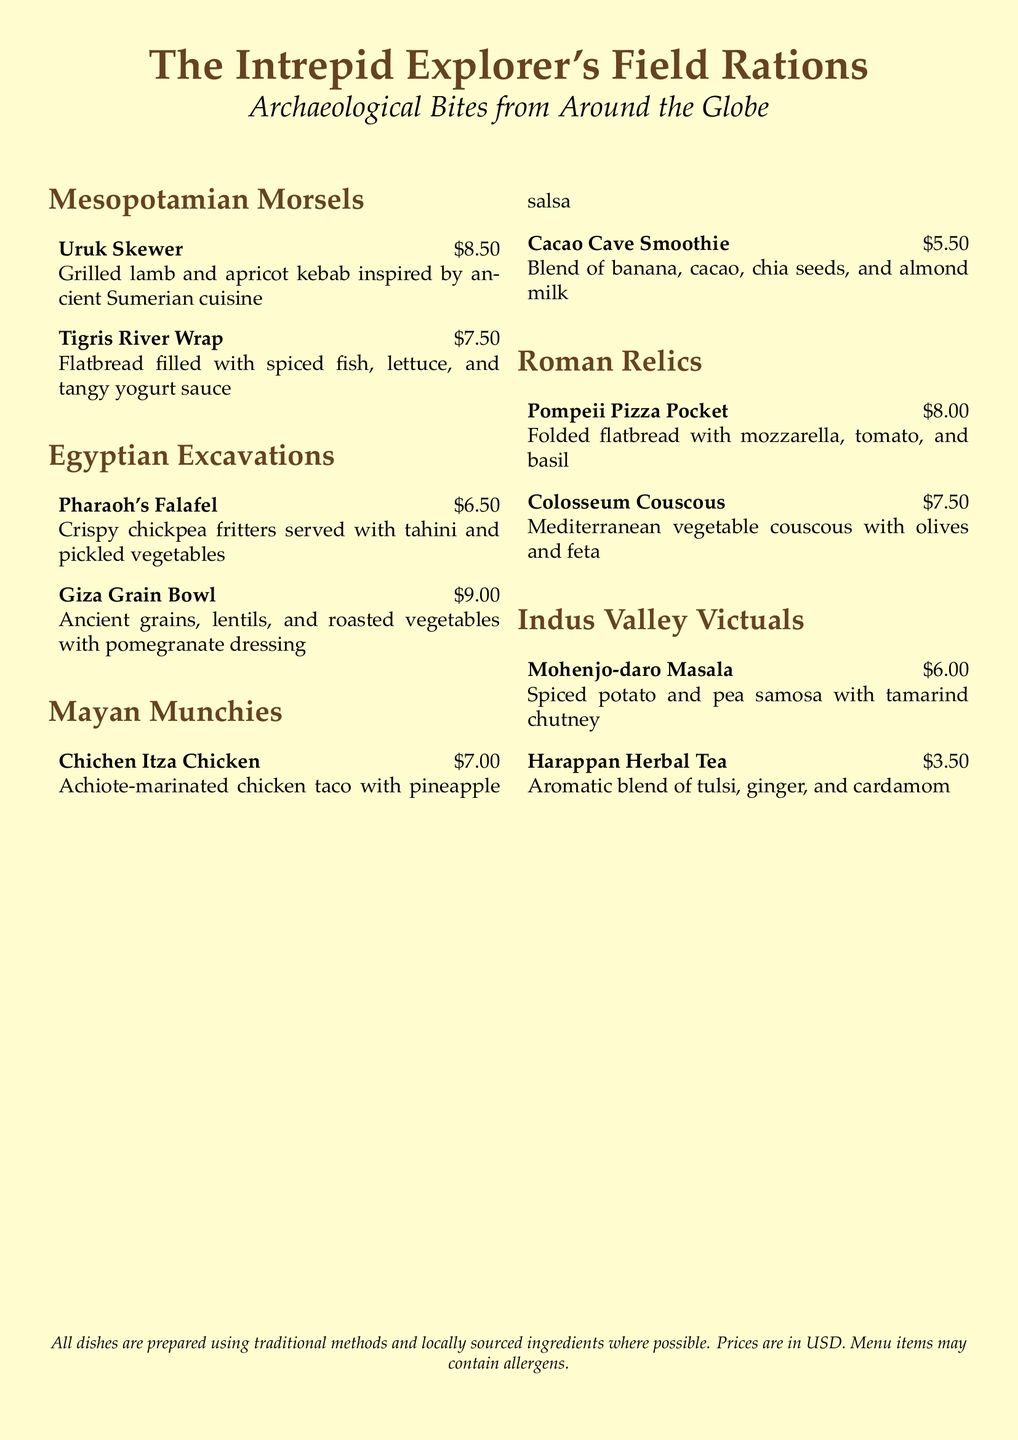What is the name of the dish inspired by Sumerian cuisine? The dish inspired by Sumerian cuisine is the Uruk Skewer.
Answer: Uruk Skewer How much does the Pharaoh's Falafel cost? The cost of the Pharaoh's Falafel is listed in the menu.
Answer: $6.50 Which snack features cacao and is a smoothie? The snack featuring cacao and is a smoothie is the Cacao Cave Smoothie.
Answer: Cacao Cave Smoothie What is the total number of sections in the menu? The menu has five sections: Mesopotamian Morsels, Egyptian Excavations, Mayan Munchies, Roman Relics, and Indus Valley Victuals.
Answer: 5 What ingredients are included in the Giza Grain Bowl? The Giza Grain Bowl includes ancient grains, lentils, and roasted vegetables with pomegranate dressing.
Answer: Ancient grains, lentils, and roasted vegetables with pomegranate dressing Which dish is associated with the Indus Valley? The dish associated with the Indus Valley is Mohenjo-daro Masala.
Answer: Mohenjo-daro Masala What beverage is offered alongside food items? The beverage offered is a herbal tea.
Answer: Herbal tea What is the price of the Colosseum Couscous? The price of the Colosseum Couscous is indicated in the price list.
Answer: $7.50 